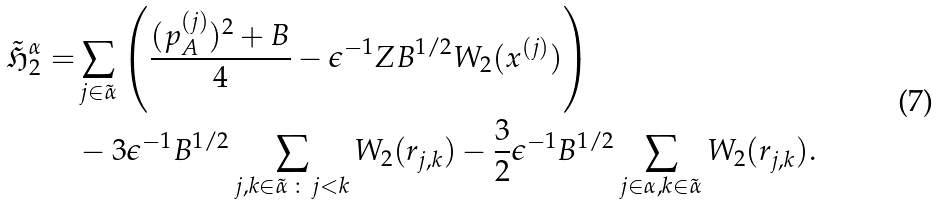Convert formula to latex. <formula><loc_0><loc_0><loc_500><loc_500>\tilde { \mathfrak H } _ { 2 } ^ { \alpha } = & \sum _ { j \in \tilde { \alpha } } \left ( \frac { ( { p } _ { A } ^ { ( j ) } ) ^ { 2 } + B } { 4 } - \epsilon ^ { - 1 } Z B ^ { 1 / 2 } W _ { 2 } ( x ^ { ( j ) } ) \right ) \\ & - 3 \epsilon ^ { - 1 } B ^ { 1 / 2 } \sum _ { j , k \in \tilde { \alpha } \, \colon \, j < k } W _ { 2 } ( r _ { j , k } ) - \frac { 3 } { 2 } \epsilon ^ { - 1 } B ^ { 1 / 2 } \sum _ { j \in \alpha , k \in \tilde { \alpha } } W _ { 2 } ( r _ { j , k } ) .</formula> 